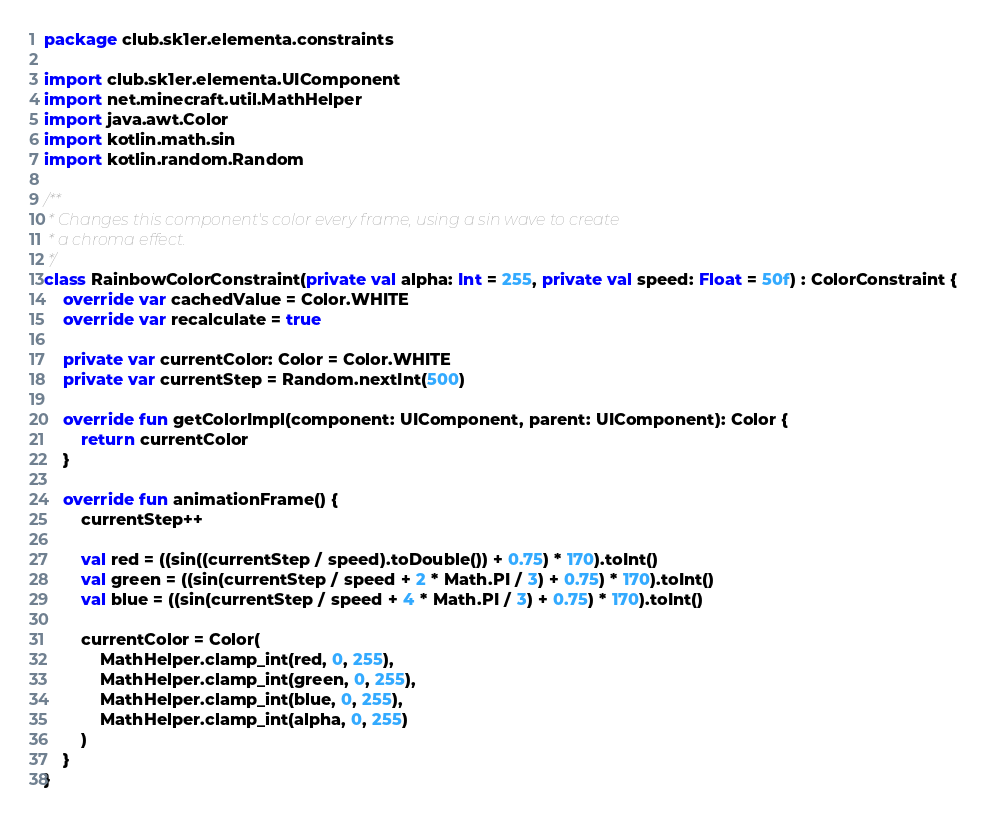Convert code to text. <code><loc_0><loc_0><loc_500><loc_500><_Kotlin_>package club.sk1er.elementa.constraints

import club.sk1er.elementa.UIComponent
import net.minecraft.util.MathHelper
import java.awt.Color
import kotlin.math.sin
import kotlin.random.Random

/**
 * Changes this component's color every frame, using a sin wave to create
 * a chroma effect.
 */
class RainbowColorConstraint(private val alpha: Int = 255, private val speed: Float = 50f) : ColorConstraint {
    override var cachedValue = Color.WHITE
    override var recalculate = true

    private var currentColor: Color = Color.WHITE
    private var currentStep = Random.nextInt(500)

    override fun getColorImpl(component: UIComponent, parent: UIComponent): Color {
        return currentColor
    }

    override fun animationFrame() {
        currentStep++

        val red = ((sin((currentStep / speed).toDouble()) + 0.75) * 170).toInt()
        val green = ((sin(currentStep / speed + 2 * Math.PI / 3) + 0.75) * 170).toInt()
        val blue = ((sin(currentStep / speed + 4 * Math.PI / 3) + 0.75) * 170).toInt()

        currentColor = Color(
            MathHelper.clamp_int(red, 0, 255),
            MathHelper.clamp_int(green, 0, 255),
            MathHelper.clamp_int(blue, 0, 255),
            MathHelper.clamp_int(alpha, 0, 255)
        )
    }
}</code> 